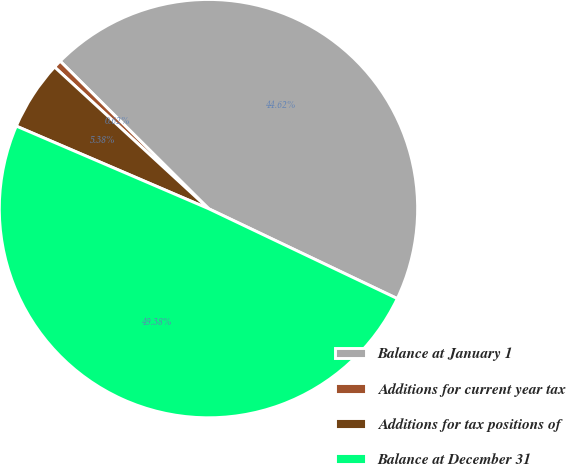Convert chart to OTSL. <chart><loc_0><loc_0><loc_500><loc_500><pie_chart><fcel>Balance at January 1<fcel>Additions for current year tax<fcel>Additions for tax positions of<fcel>Balance at December 31<nl><fcel>44.62%<fcel>0.62%<fcel>5.38%<fcel>49.38%<nl></chart> 